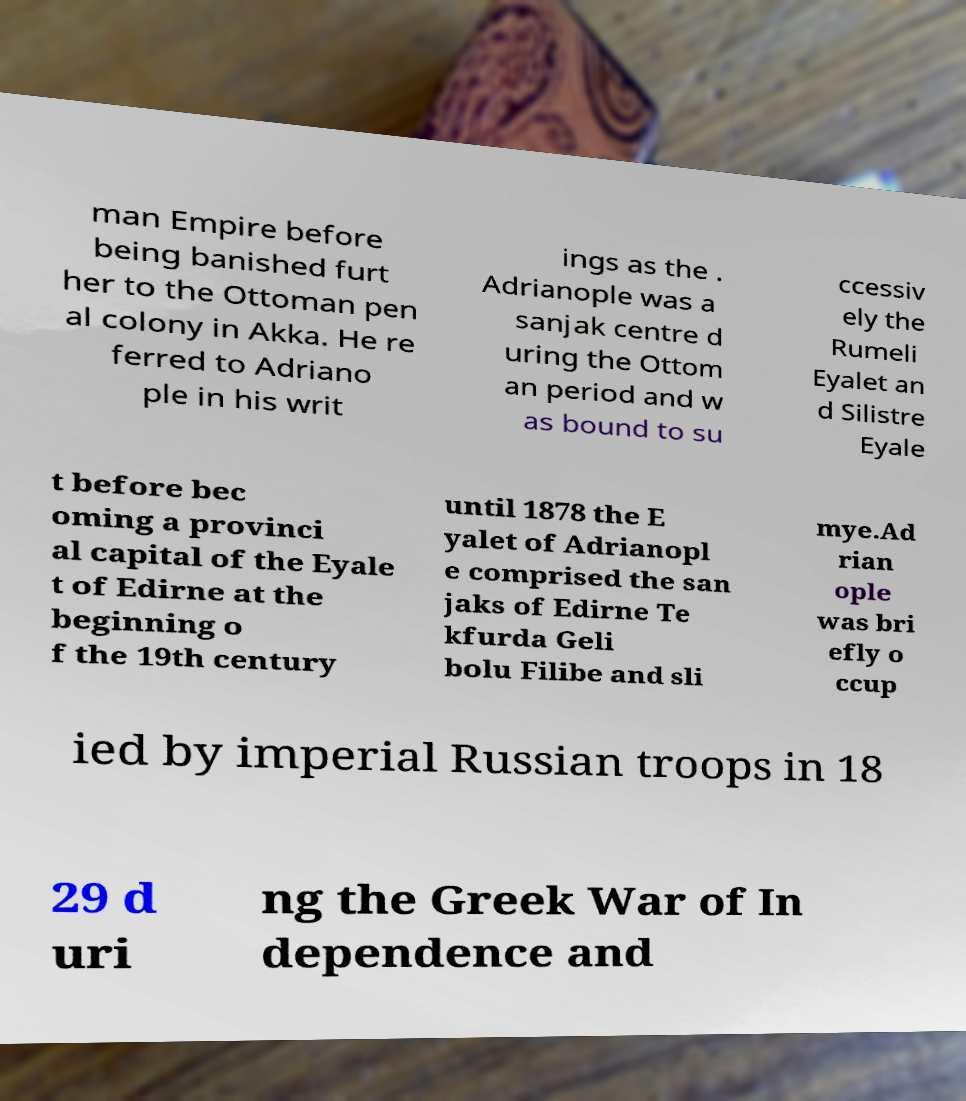What messages or text are displayed in this image? I need them in a readable, typed format. man Empire before being banished furt her to the Ottoman pen al colony in Akka. He re ferred to Adriano ple in his writ ings as the . Adrianople was a sanjak centre d uring the Ottom an period and w as bound to su ccessiv ely the Rumeli Eyalet an d Silistre Eyale t before bec oming a provinci al capital of the Eyale t of Edirne at the beginning o f the 19th century until 1878 the E yalet of Adrianopl e comprised the san jaks of Edirne Te kfurda Geli bolu Filibe and sli mye.Ad rian ople was bri efly o ccup ied by imperial Russian troops in 18 29 d uri ng the Greek War of In dependence and 